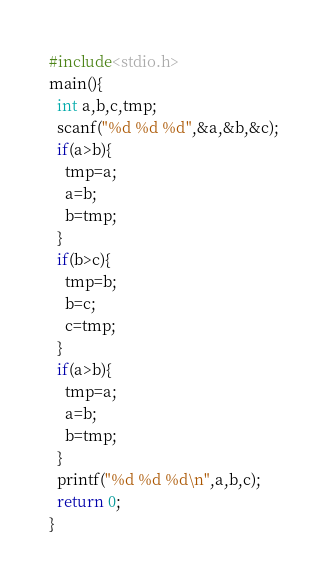<code> <loc_0><loc_0><loc_500><loc_500><_C_>#include<stdio.h>
main(){
  int a,b,c,tmp;
  scanf("%d %d %d",&a,&b,&c);
  if(a>b){
    tmp=a;
    a=b;
    b=tmp;
  }
  if(b>c){
    tmp=b;
    b=c;
    c=tmp;
  }
  if(a>b){
    tmp=a;
    a=b;
    b=tmp;
  }
  printf("%d %d %d\n",a,b,c);
  return 0;
}
</code> 